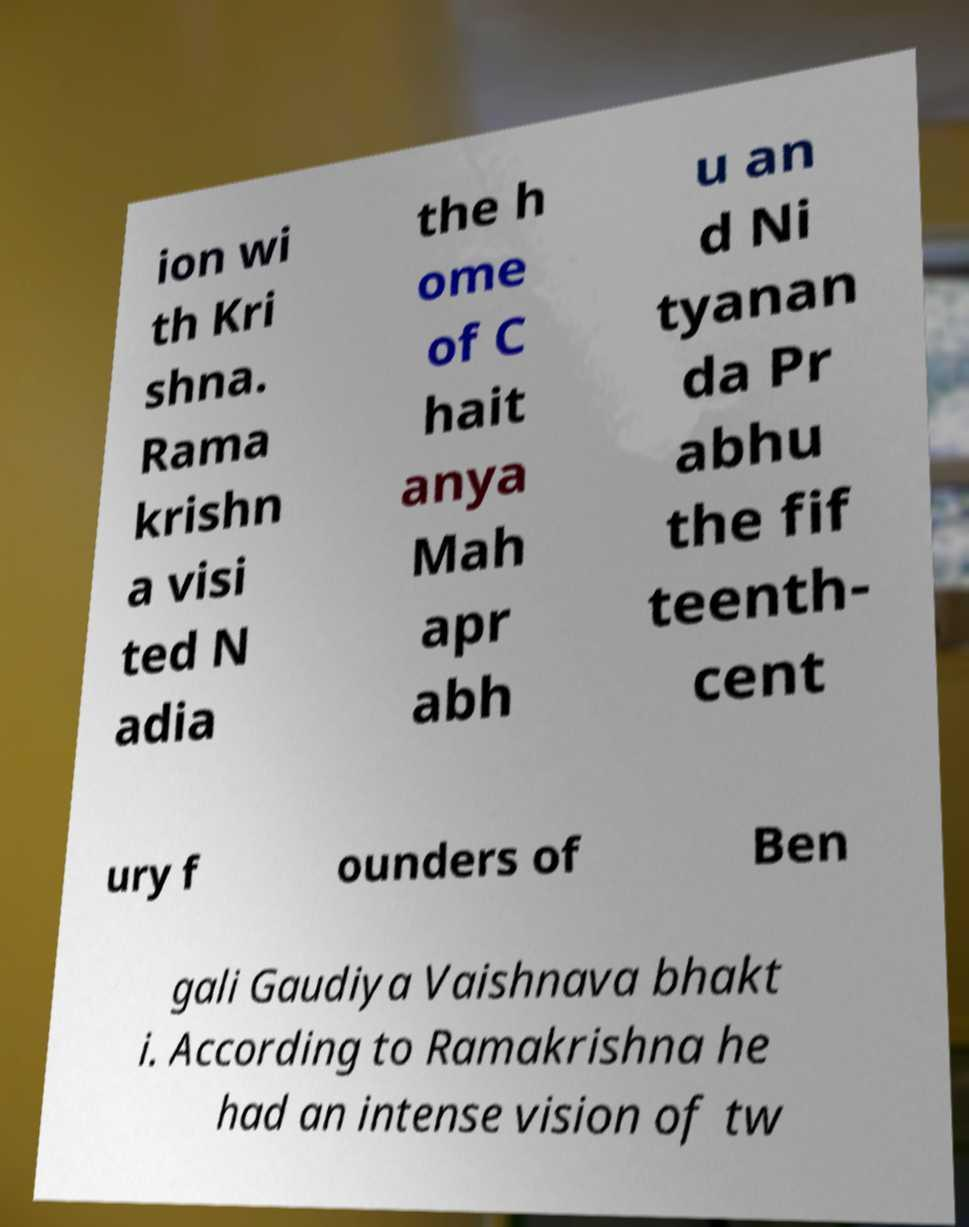There's text embedded in this image that I need extracted. Can you transcribe it verbatim? ion wi th Kri shna. Rama krishn a visi ted N adia the h ome of C hait anya Mah apr abh u an d Ni tyanan da Pr abhu the fif teenth- cent ury f ounders of Ben gali Gaudiya Vaishnava bhakt i. According to Ramakrishna he had an intense vision of tw 